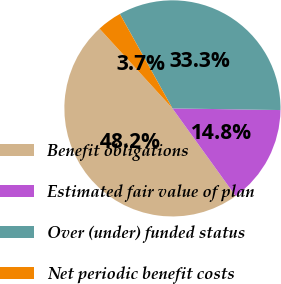<chart> <loc_0><loc_0><loc_500><loc_500><pie_chart><fcel>Benefit obligations<fcel>Estimated fair value of plan<fcel>Over (under) funded status<fcel>Net periodic benefit costs<nl><fcel>48.15%<fcel>14.81%<fcel>33.33%<fcel>3.7%<nl></chart> 